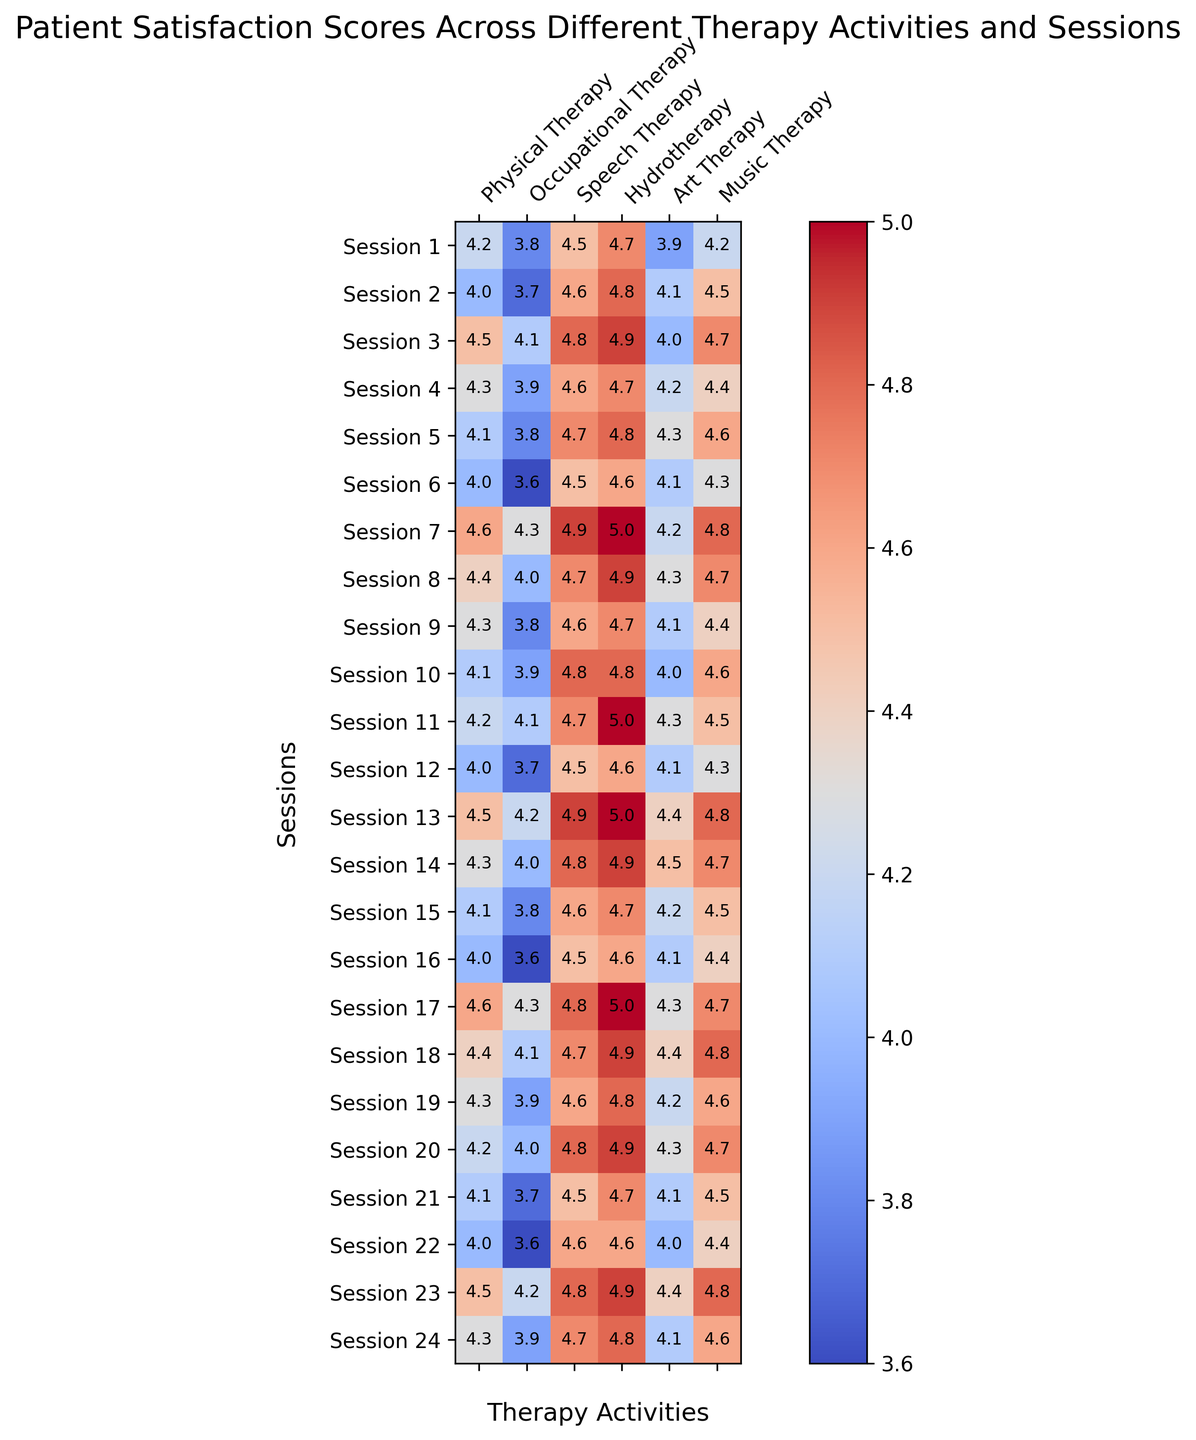Which type of therapy shows the highest patient satisfaction in Session 7? To determine which therapy has the highest satisfaction score in Session 7, find the row for Session 7 and look at each therapy column: Physical Therapy (4.6), Occupational Therapy (4.3), Speech Therapy (4.9), Hydrotherapy (5.0), Art Therapy (4.2), Music Therapy (4.8). Hydrotherapy has the highest score of 5.0.
Answer: Hydrotherapy Which session has the lowest satisfaction score for Occupational Therapy? Locate the Occupational Therapy column and identify the session with the lowest value. The lowest scores are 3.6, which occur in Sessions 6, 16, and 22.
Answer: Session 6, 16, 22 What is the average satisfaction score for Music Therapy across all sessions? Add all the Music Therapy scores and divide by the number of sessions: (4.2 + 4.5 + 4.7 + 4.4 + 4.6 + 4.3 + 4.8 + 4.7 + 4.4 + 4.6 + 4.5 + 4.3 + 4.8 + 4.7 + 4.5 + 4.4 + 4.7 + 4.8 + 4.6 + 4.7 + 4.5 + 4.4 + 4.8 + 4.6) / 24 = 4.54
Answer: 4.54 In which session did Art Therapy receive its highest satisfaction score? Locate the Art Therapy column and find the highest value. The highest score is 4.5 in Sessions 14.
Answer: Session 14 Which therapy had the most consistent satisfaction scores across sessions? Consistency can be determined by the least variation in scores. Looking at the range (difference between highest and lowest score): Physical Therapy (4.6 - 4.0 = 0.6), Occupational Therapy (4.3 - 3.6 = 0.7), Speech Therapy (4.9 - 4.5 = 0.4), Hydrotherapy (5.0 - 4.6 = 0.4), Art Therapy (4.5 - 3.9 = 0.6), and Music Therapy (4.8 - 4.2 = 0.6), Speech Therapy and Hydrotherapy both have the smallest range of 0.4.
Answer: Speech Therapy, Hydrotherapy Which two types of therapy have the closest average satisfaction scores? Calculate average scores for each therapy: 
Physical Therapy = 4.25, 
Occupational Therapy = 3.88, 
Speech Therapy = 4.68, 
Hydrotherapy = 4.83, 
Art Therapy = 4.22, 
Music Therapy = 4.56.
The closest averages are Art Therapy (4.22) and Physical Therapy (4.25).
Answer: Physical Therapy, Art Therapy 